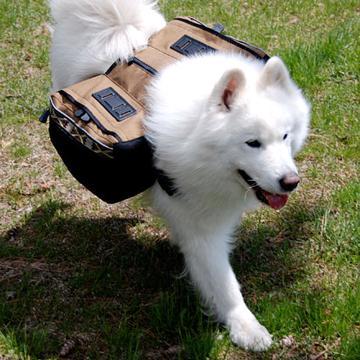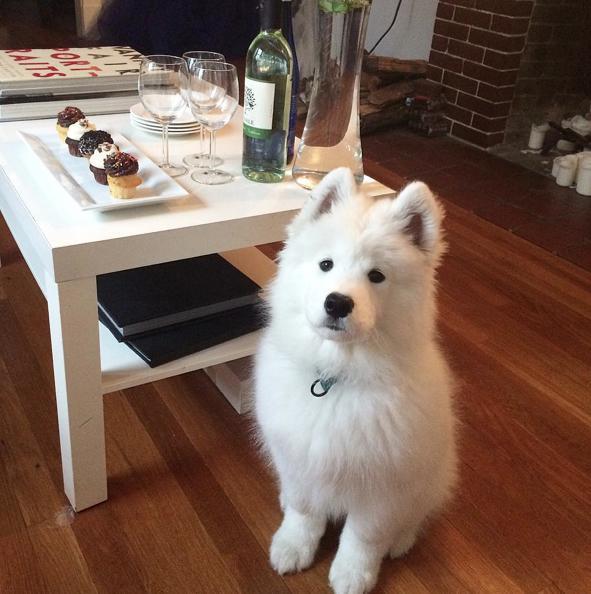The first image is the image on the left, the second image is the image on the right. For the images displayed, is the sentence "A dog is on a wooden floor." factually correct? Answer yes or no. Yes. The first image is the image on the left, the second image is the image on the right. Given the left and right images, does the statement "a dog is indoors on a wooden floor" hold true? Answer yes or no. Yes. 